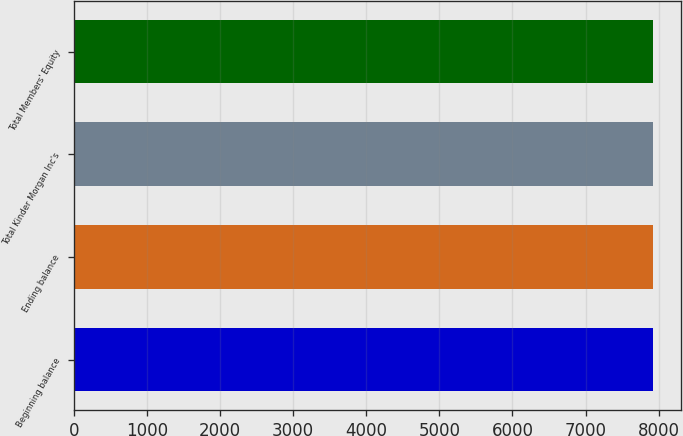Convert chart. <chart><loc_0><loc_0><loc_500><loc_500><bar_chart><fcel>Beginning balance<fcel>Ending balance<fcel>Total Kinder Morgan Inc's<fcel>Total Members' Equity<nl><fcel>7914.4<fcel>7914.5<fcel>7914.6<fcel>7914.7<nl></chart> 